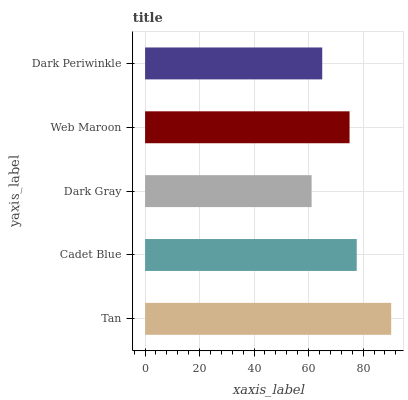Is Dark Gray the minimum?
Answer yes or no. Yes. Is Tan the maximum?
Answer yes or no. Yes. Is Cadet Blue the minimum?
Answer yes or no. No. Is Cadet Blue the maximum?
Answer yes or no. No. Is Tan greater than Cadet Blue?
Answer yes or no. Yes. Is Cadet Blue less than Tan?
Answer yes or no. Yes. Is Cadet Blue greater than Tan?
Answer yes or no. No. Is Tan less than Cadet Blue?
Answer yes or no. No. Is Web Maroon the high median?
Answer yes or no. Yes. Is Web Maroon the low median?
Answer yes or no. Yes. Is Dark Periwinkle the high median?
Answer yes or no. No. Is Tan the low median?
Answer yes or no. No. 